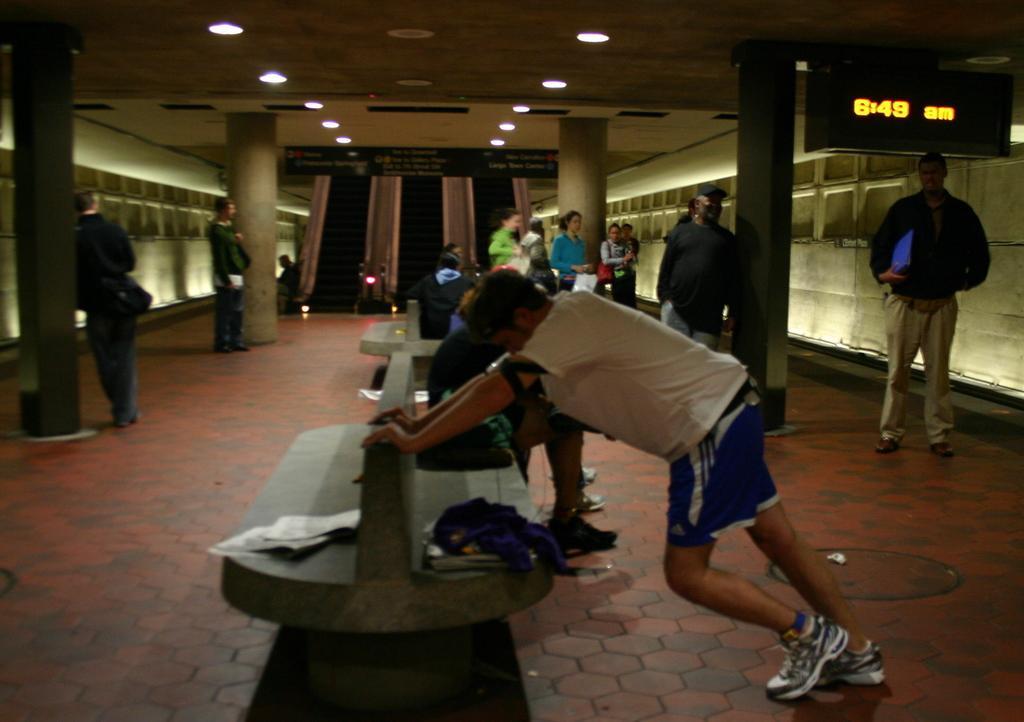In one or two sentences, can you explain what this image depicts? In this image there is a person holding the bench having papers, clothes and few objects. People are sitting on the benches. Few people are standing on the floor. There are boards and lights attached to the roof. There are pillars attached to the roof. Background there is a wall. Right side there is person holding an object. 